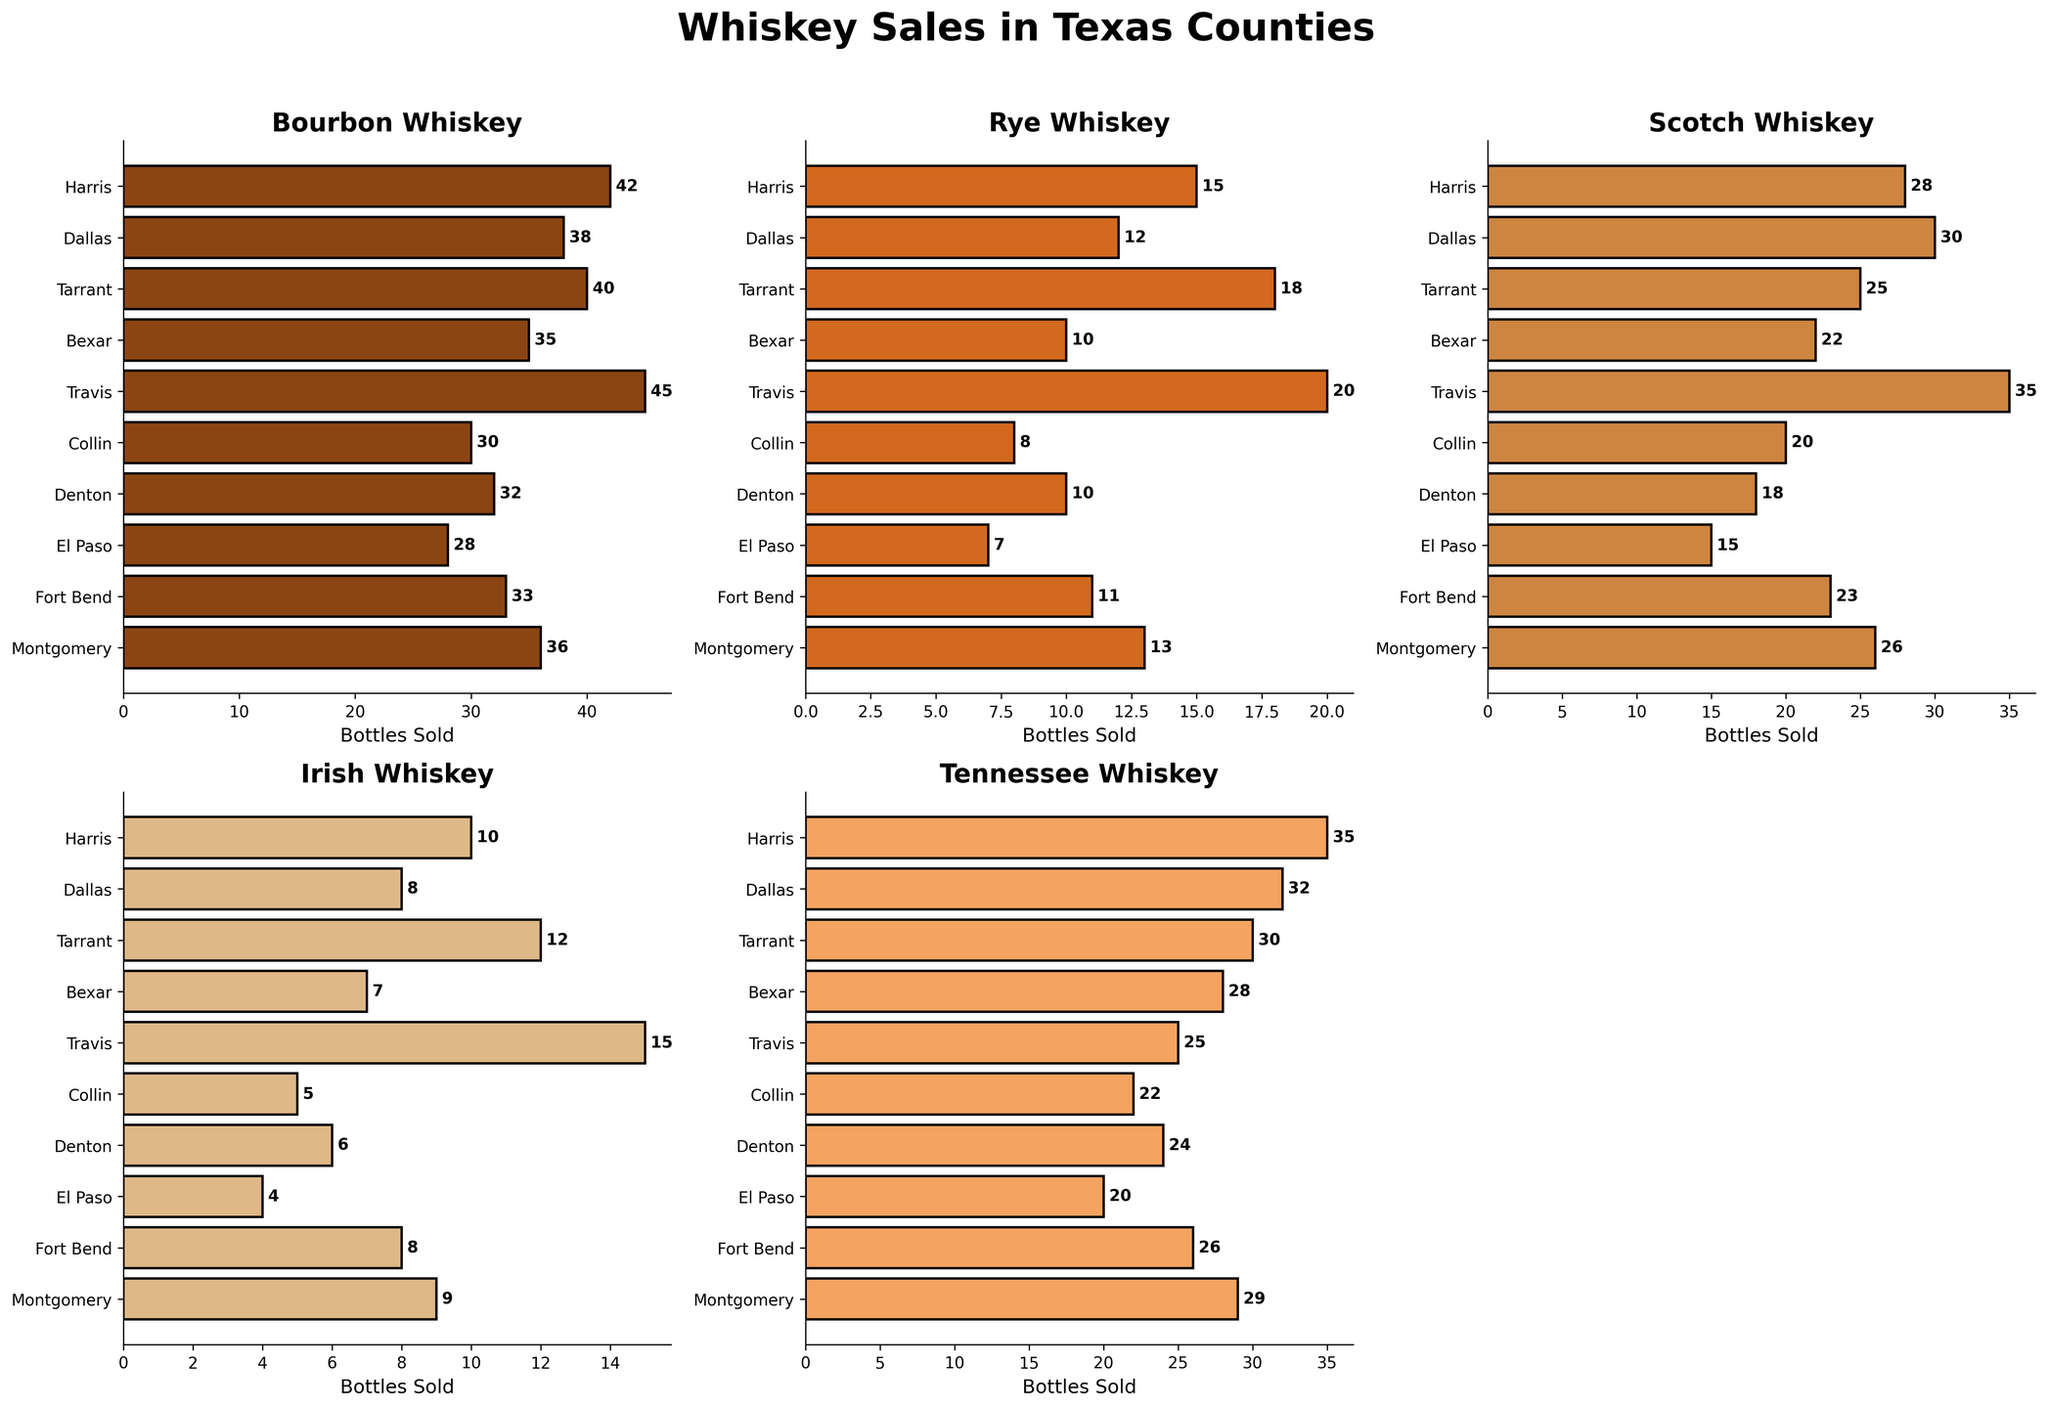Which county has the highest Bourbon sales? Look at the Bourbon subplot and find the highest bar, which belongs to Travis County.
Answer: Travis County Which whiskey type has the lowest sales in El Paso County? Check for the smallest bar in each subplot specific to El Paso County. The smallest bar is in the Irish subplot.
Answer: Irish How many bottles of Rye whiskey were sold in Montgomery County? Look at the Rye subplot and read the bar value next to Montgomery County.
Answer: 13 Which county sold more Tennessee whiskey: Harris or Dallas? Compare the Tennessee whiskey bars for Harris and Dallas in the Tennessee subplot. Harris has a higher value than Dallas.
Answer: Harris What's the total sales of Scotch whiskey across all counties? Add up all the values in the Scotch subplot: 28 + 30 + 25 + 22 + 35 + 20 + 18 + 15 + 23 + 26 = 242.
Answer: 242 Which county sold the fewest number of whiskeys in general? Calculate the sum of all whiskey types for each county and find the smallest one. El Paso has the lowest total sum of 28 + 7 + 15 + 4 + 20 = 74.
Answer: El Paso Compare Bourbon sales in Harris and Tarrant counties. Which one sold more, and by how much? Find the Bourbon sales for both counties: Harris (42) and Tarrant (40). Harris sold 42 - 40 = 2 more bottles than Tarrant.
Answer: Harris, 2 more Which whiskey type had the highest average sales across all counties? Calculate the average sales for each whiskey type: 
1. Bourbon: (42 + 38 + 40 + 35 + 45 + 30 + 32 + 28 + 33 + 36) / 10 = 35.9
2. Rye: (15 + 12 + 18 + 10 + 20 + 8 + 10 + 7 + 11 + 13) / 10 = 12.4
3. Scotch: (28 + 30 + 25 + 22 + 35 + 20 + 18 + 15 + 23 + 26) / 10 = 24.2
4. Irish: (10 + 8 + 12 + 7 + 15 + 5 + 6 + 4 + 8 + 9) / 10 = 8.4
5. Tennessee: (35 + 32 + 30 + 28 + 25 + 22 + 24 + 20 + 26 + 29) / 10 = 27.1
Bourbon has the highest average at 35.9
Answer: Bourbon 